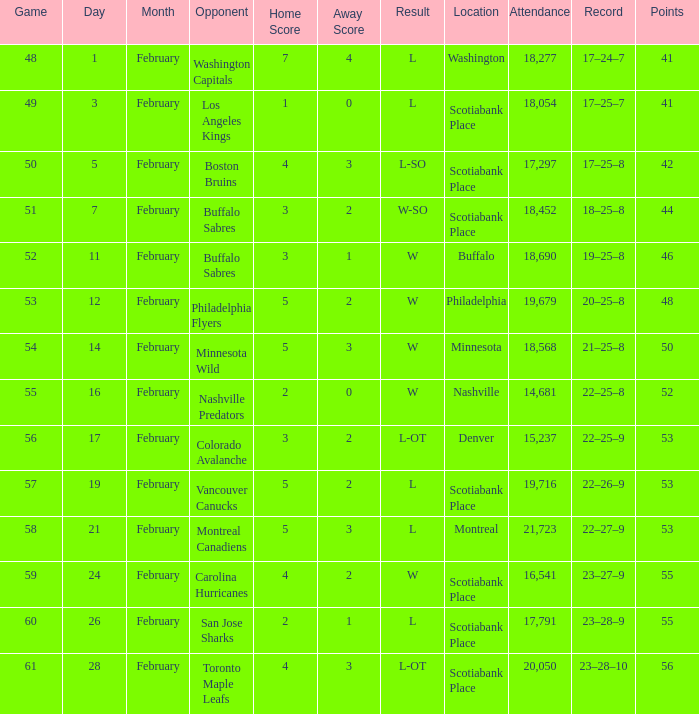What sum of game has an attendance of 18,690? 52.0. Parse the table in full. {'header': ['Game', 'Day', 'Month', 'Opponent', 'Home Score', 'Away Score', 'Result', 'Location', 'Attendance', 'Record', 'Points'], 'rows': [['48', '1', 'February', 'Washington Capitals', '7', '4', 'L', 'Washington', '18,277', '17–24–7', '41'], ['49', '3', 'February', 'Los Angeles Kings', '1', '0', 'L', 'Scotiabank Place', '18,054', '17–25–7', '41'], ['50', '5', 'February', 'Boston Bruins', '4', '3', 'L-SO', 'Scotiabank Place', '17,297', '17–25–8', '42'], ['51', '7', 'February', 'Buffalo Sabres', '3', '2', 'W-SO', 'Scotiabank Place', '18,452', '18–25–8', '44'], ['52', '11', 'February', 'Buffalo Sabres', '3', '1', 'W', 'Buffalo', '18,690', '19–25–8', '46'], ['53', '12', 'February', 'Philadelphia Flyers', '5', '2', 'W', 'Philadelphia', '19,679', '20–25–8', '48'], ['54', '14', 'February', 'Minnesota Wild', '5', '3', 'W', 'Minnesota', '18,568', '21–25–8', '50'], ['55', '16', 'February', 'Nashville Predators', '2', '0', 'W', 'Nashville', '14,681', '22–25–8', '52'], ['56', '17', 'February', 'Colorado Avalanche', '3', '2', 'L-OT', 'Denver', '15,237', '22–25–9', '53'], ['57', '19', 'February', 'Vancouver Canucks', '5', '2', 'L', 'Scotiabank Place', '19,716', '22–26–9', '53'], ['58', '21', 'February', 'Montreal Canadiens', '5', '3', 'L', 'Montreal', '21,723', '22–27–9', '53'], ['59', '24', 'February', 'Carolina Hurricanes', '4', '2', 'W', 'Scotiabank Place', '16,541', '23–27–9', '55'], ['60', '26', 'February', 'San Jose Sharks', '2', '1', 'L', 'Scotiabank Place', '17,791', '23–28–9', '55'], ['61', '28', 'February', 'Toronto Maple Leafs', '4', '3', 'L-OT', 'Scotiabank Place', '20,050', '23–28–10', '56']]} 